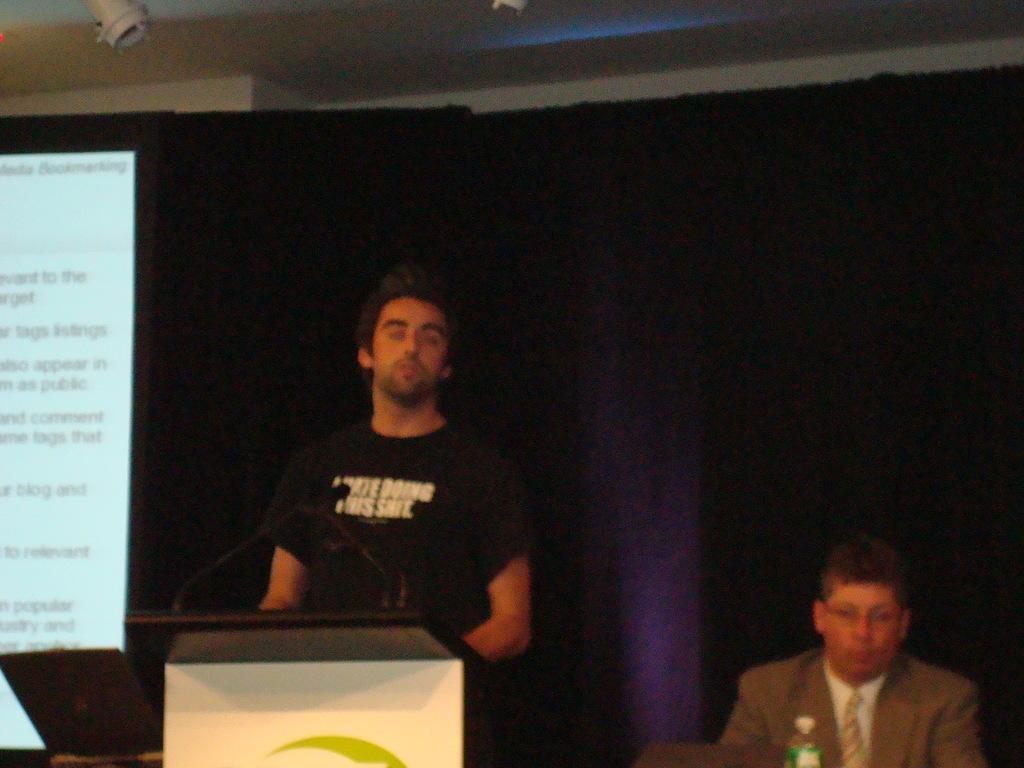Can you describe this image briefly? In this picture I can observe two men. One of them is standing in front of a podium. On the left side I can observe screen. In the background I can observe curtain. 